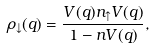<formula> <loc_0><loc_0><loc_500><loc_500>\rho _ { \downarrow } ( q ) = \frac { V ( q ) n _ { \uparrow } V ( q ) } { 1 - n V ( q ) } ,</formula> 